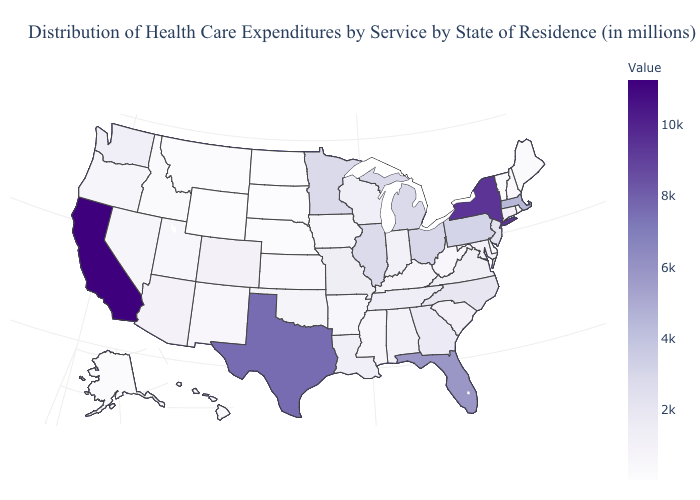Does Wyoming have the lowest value in the USA?
Concise answer only. Yes. Among the states that border North Carolina , which have the highest value?
Give a very brief answer. Georgia. Does Minnesota have a higher value than California?
Be succinct. No. Among the states that border Missouri , does Nebraska have the lowest value?
Write a very short answer. Yes. Among the states that border California , which have the highest value?
Write a very short answer. Arizona. 